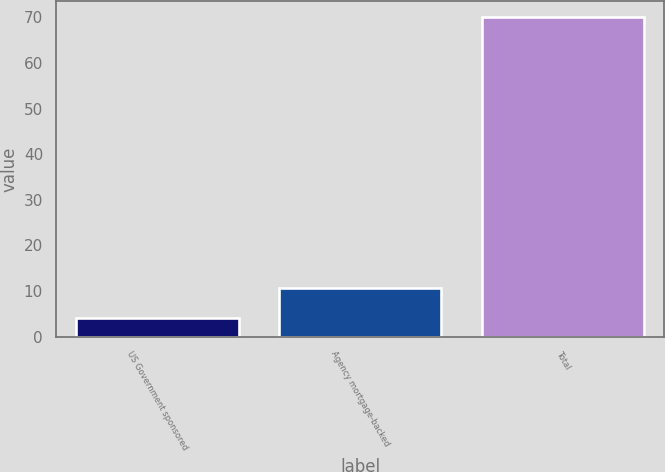Convert chart. <chart><loc_0><loc_0><loc_500><loc_500><bar_chart><fcel>US Government sponsored<fcel>Agency mortgage-backed<fcel>Total<nl><fcel>4<fcel>10.6<fcel>70<nl></chart> 